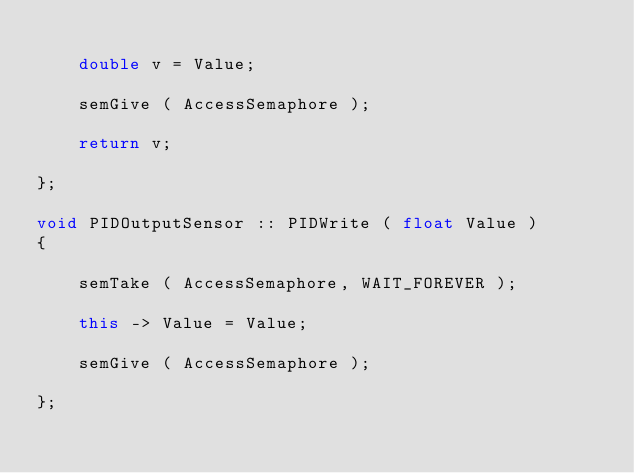<code> <loc_0><loc_0><loc_500><loc_500><_C++_>
	double v = Value;
	
	semGive ( AccessSemaphore );

	return v;

};

void PIDOutputSensor :: PIDWrite ( float Value )
{

	semTake ( AccessSemaphore, WAIT_FOREVER );

	this -> Value = Value;

	semGive ( AccessSemaphore );

};
</code> 